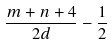Convert formula to latex. <formula><loc_0><loc_0><loc_500><loc_500>\frac { m + n + 4 } { 2 d } - \frac { 1 } { 2 }</formula> 